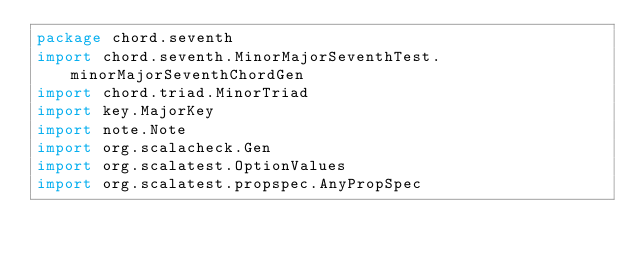<code> <loc_0><loc_0><loc_500><loc_500><_Scala_>package chord.seventh
import chord.seventh.MinorMajorSeventhTest.minorMajorSeventhChordGen
import chord.triad.MinorTriad
import key.MajorKey
import note.Note
import org.scalacheck.Gen
import org.scalatest.OptionValues
import org.scalatest.propspec.AnyPropSpec</code> 